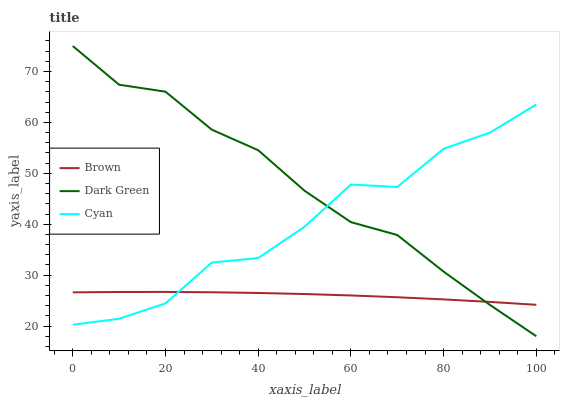Does Brown have the minimum area under the curve?
Answer yes or no. Yes. Does Dark Green have the maximum area under the curve?
Answer yes or no. Yes. Does Cyan have the minimum area under the curve?
Answer yes or no. No. Does Cyan have the maximum area under the curve?
Answer yes or no. No. Is Brown the smoothest?
Answer yes or no. Yes. Is Cyan the roughest?
Answer yes or no. Yes. Is Dark Green the smoothest?
Answer yes or no. No. Is Dark Green the roughest?
Answer yes or no. No. Does Cyan have the lowest value?
Answer yes or no. No. Does Cyan have the highest value?
Answer yes or no. No. 